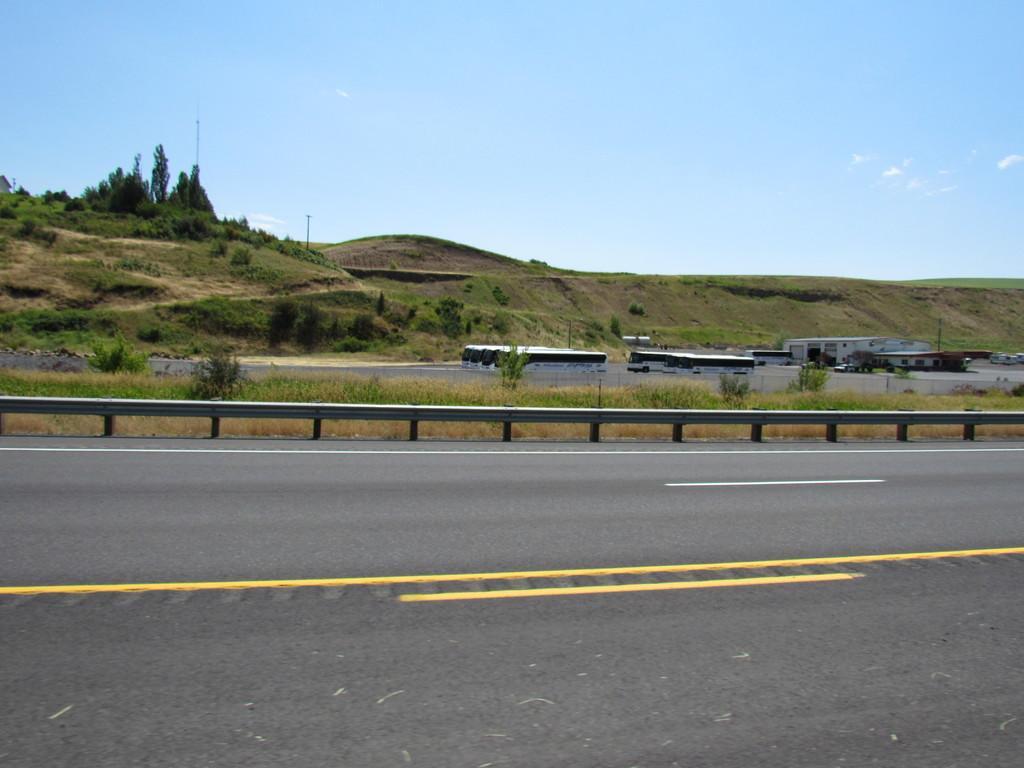Describe this image in one or two sentences. In this image there are a few vehicles on the road, there are few buildings, few trees, plants and the sky. 